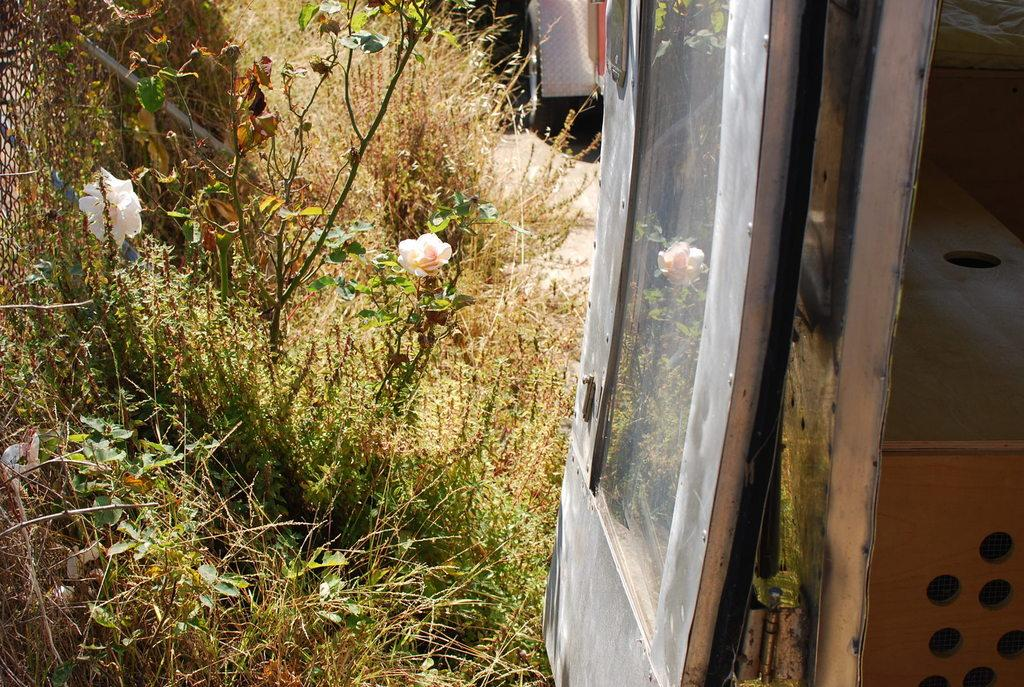What type of vehicle is in the picture? There is a vehicle in the picture, but the specific type is not mentioned in the facts. What is the purpose of the bed in the picture? The purpose of the bed in the picture is not mentioned in the facts. What is the function of the door in the picture? The function of the door in the picture is not mentioned in the facts. What type of plants are in the picture? The type of plants in the picture is not mentioned in the facts. What color are the flowers in the picture? The color of the flowers in the picture is not mentioned in the facts. Can you describe any other objects in the picture? There are other objects in the picture, but their specific details are not mentioned in the facts. What type of hydrant is visible in the picture? There is no hydrant present in the picture. What type of jail can be seen in the picture? There is no jail present in the picture. 